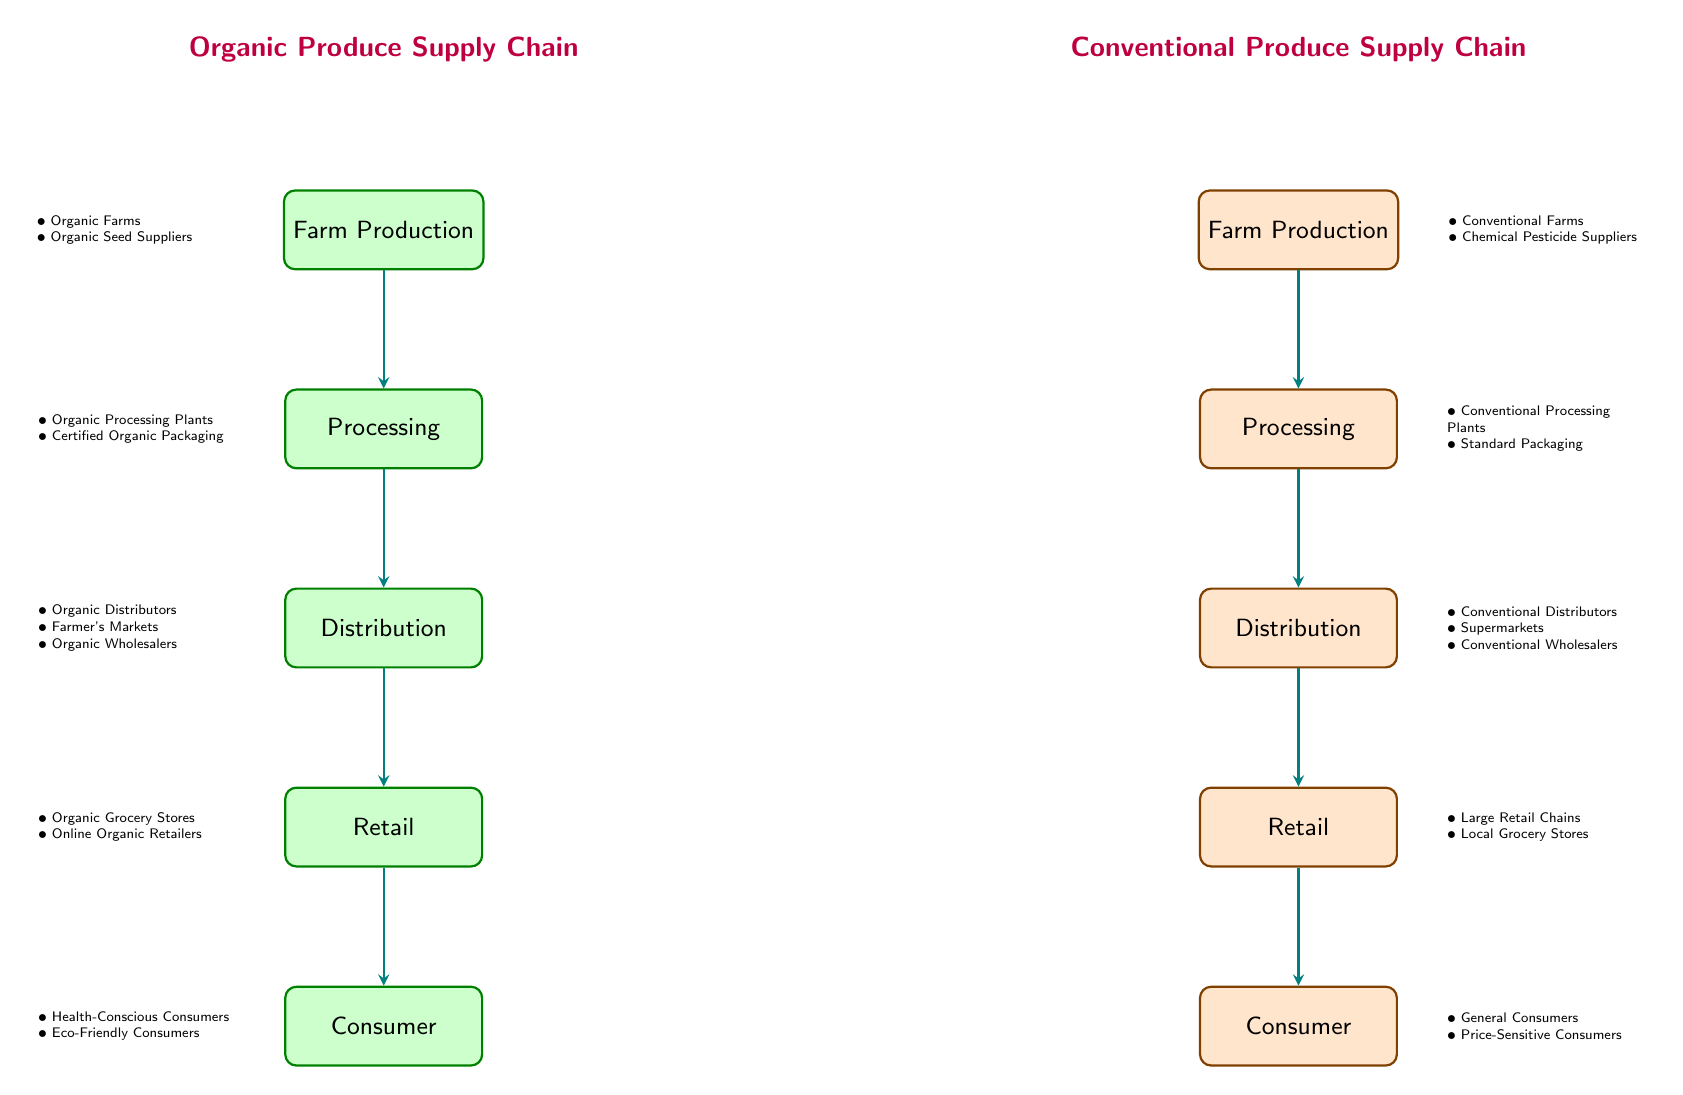What is the first stage of the organic produce supply chain? The organic produce supply chain starts with "Farm Production," as indicated by the first node in that section of the diagram.
Answer: Farm Production How many stages are there in the conventional produce supply chain? The conventional produce supply chain consists of five stages: Farm Production, Processing, Distribution, Retail, and Consumer. Counting these gives a total of five stages.
Answer: 5 Who are the consumers for organic produce? According to the diagram, the consumers for organic produce are "Health-Conscious Consumers" and "Eco-Friendly Consumers," which are listed in the consumer node of the organic supply chain.
Answer: Health-Conscious Consumers, Eco-Friendly Consumers What processing method is used in conventional processing? The conventional processing section specifies that "Standard Packaging" is the processing method used, implying a conventional approach to produce packaging.
Answer: Standard Packaging In what way does the distribution of organic produce differ from that of conventional produce? The organic distribution includes "Organic Distributors," "Farmer's Markets," and "Organic Wholesalers," whereas the conventional distribution consists mainly of "Conventional Distributors," "Supermarkets," and "Conventional Wholesalers." This indicates a broader range of distribution methods for organic produce aligned with niche markets.
Answer: Broader range for organic, including Farmer's Markets What type of consumers are indicated for conventional produce? The conventional produce section identifies "General Consumers" and "Price-Sensitive Consumers," referring to the demographics that typically purchase conventional produce.
Answer: General Consumers, Price-Sensitive Consumers Which supply chain has a title assigned to its processing stage? Both supply chains have titles, but "Organic Produce Supply Chain" and "Conventional Produce Supply Chain" are specific to their overall supply processes rather than the processing stage itself. However, only the node of the organic supply chain gives detail about organic processing. Thus, while there's a title for each supply chain, the focus of processing is only detailed in the organic section.
Answer: Organic Produce Supply Chain Identify one type of supplier for organic farms. The diagram shows "Organic Seed Suppliers" as one category of suppliers integral to organic farms, mentioned together with "Organic Farms."
Answer: Organic Seed Suppliers What is the color coding for the nodes in conventional production? The nodes in conventional production are color-coded orange, which distinguishes them from the green-coded nodes representing organic production. This color scheme visually differentiates the two supply chains.
Answer: Orange 